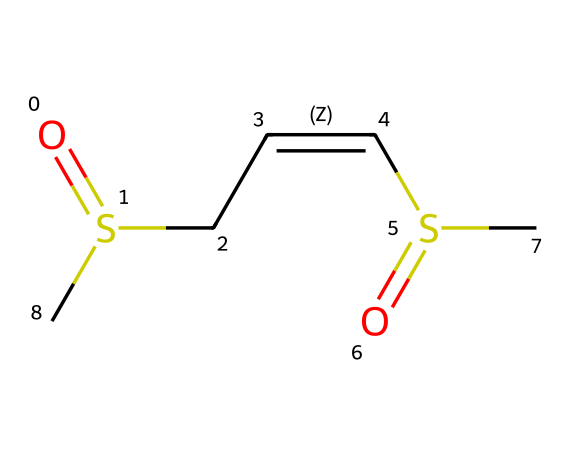What is the total number of sulfur atoms in allicin? The SMILES representation shows two sulfur atoms (S) connected to other groups in the molecular structure. By counting these, we determine the total number.
Answer: two What type of chemical compound is allicin? Allicin, based on the presence of sulfur in its structure along with carbon and hydrogen, is classified as an organosulfur compound.
Answer: organosulfur How many double bonds are present in allicin? Examining the structure, there is one double bond between the carbon atoms (C/C) and another between the sulfur and carbon atoms, totaling two.
Answer: two What functional groups are evident in the allicin structure? The allicin structure contains a sulfoxide functional group (due to the SO) and an alkene functional group (C=C), indicating both are present.
Answer: sulfoxide and alkene What is the significance of the double bond in the chemical structure of allicin? The double bond contributes to the reactivity of allicin, making it effective in biochemistry for interactions such as with enzymes or in biological processes.
Answer: reactivity Does allicin exhibit any stereochemistry? The presence of the double bond between carbon atoms suggests that there may be cis or trans configurations; however, the SMILES notation does not specify stereochemical details explicitly.
Answer: no specific stereochemistry indicated 